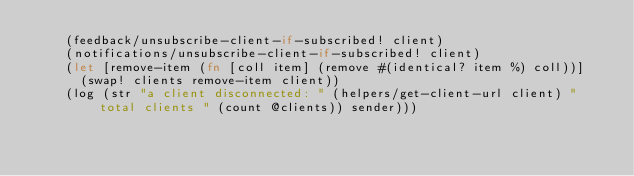<code> <loc_0><loc_0><loc_500><loc_500><_Clojure_>    (feedback/unsubscribe-client-if-subscribed! client)
    (notifications/unsubscribe-client-if-subscribed! client)
    (let [remove-item (fn [coll item] (remove #(identical? item %) coll))]
      (swap! clients remove-item client))
    (log (str "a client disconnected: " (helpers/get-client-url client) " total clients " (count @clients)) sender)))
</code> 